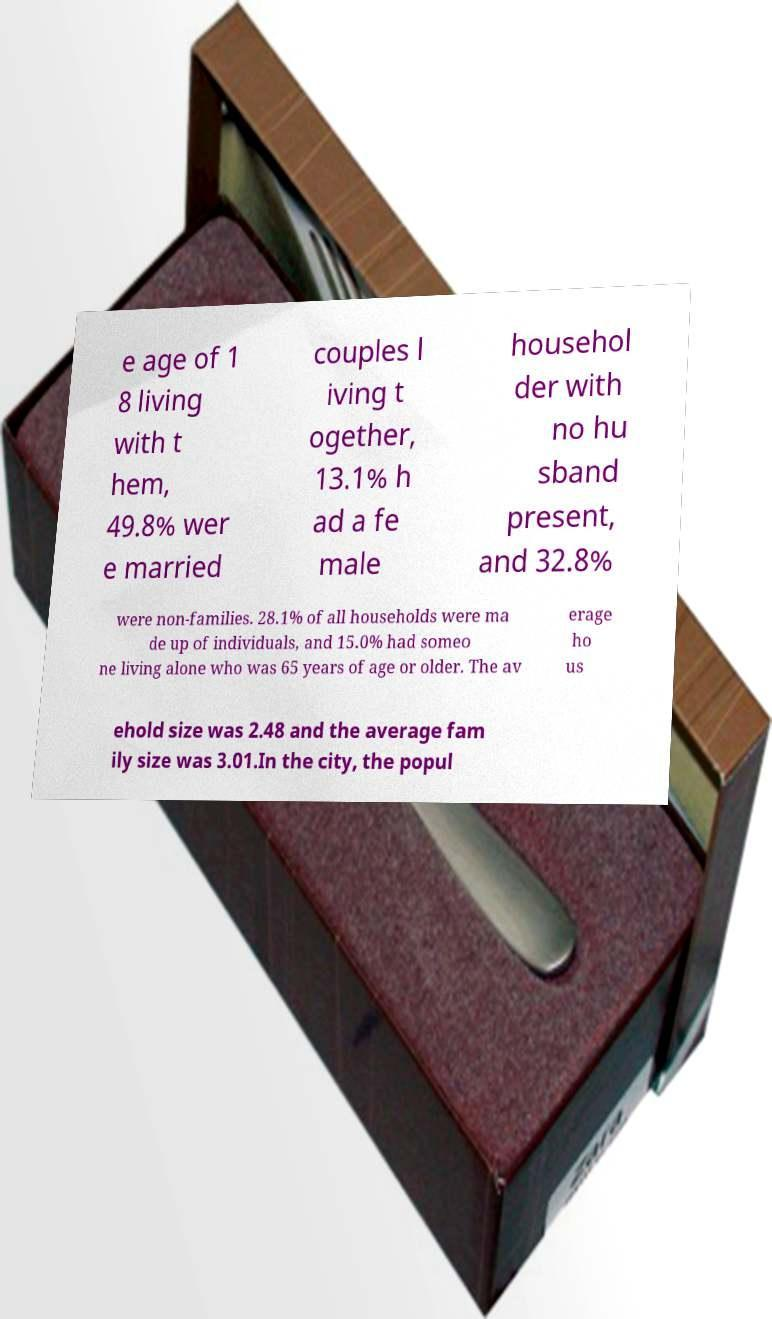Please identify and transcribe the text found in this image. e age of 1 8 living with t hem, 49.8% wer e married couples l iving t ogether, 13.1% h ad a fe male househol der with no hu sband present, and 32.8% were non-families. 28.1% of all households were ma de up of individuals, and 15.0% had someo ne living alone who was 65 years of age or older. The av erage ho us ehold size was 2.48 and the average fam ily size was 3.01.In the city, the popul 